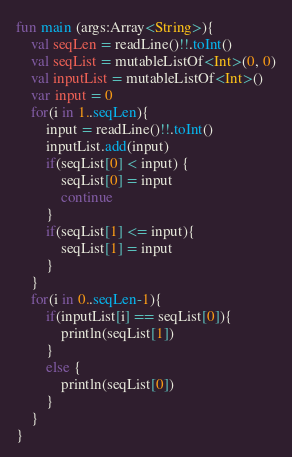Convert code to text. <code><loc_0><loc_0><loc_500><loc_500><_Kotlin_>fun main (args:Array<String>){
    val seqLen = readLine()!!.toInt()
    val seqList = mutableListOf<Int>(0, 0)
    val inputList = mutableListOf<Int>()
    var input = 0
    for(i in 1..seqLen){
        input = readLine()!!.toInt()
        inputList.add(input)
        if(seqList[0] < input) {
            seqList[0] = input
            continue
        }
        if(seqList[1] <= input){
            seqList[1] = input
        }
    }
    for(i in 0..seqLen-1){
        if(inputList[i] == seqList[0]){
            println(seqList[1])
        }
        else {
            println(seqList[0])
        }
    }
}</code> 